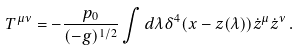Convert formula to latex. <formula><loc_0><loc_0><loc_500><loc_500>T ^ { \mu \nu } = - \frac { p _ { 0 } } { ( - g ) ^ { 1 / 2 } } \int d \lambda \delta ^ { 4 } ( x - z ( \lambda ) ) \dot { z } ^ { \mu } \dot { z } ^ { \nu } \, .</formula> 